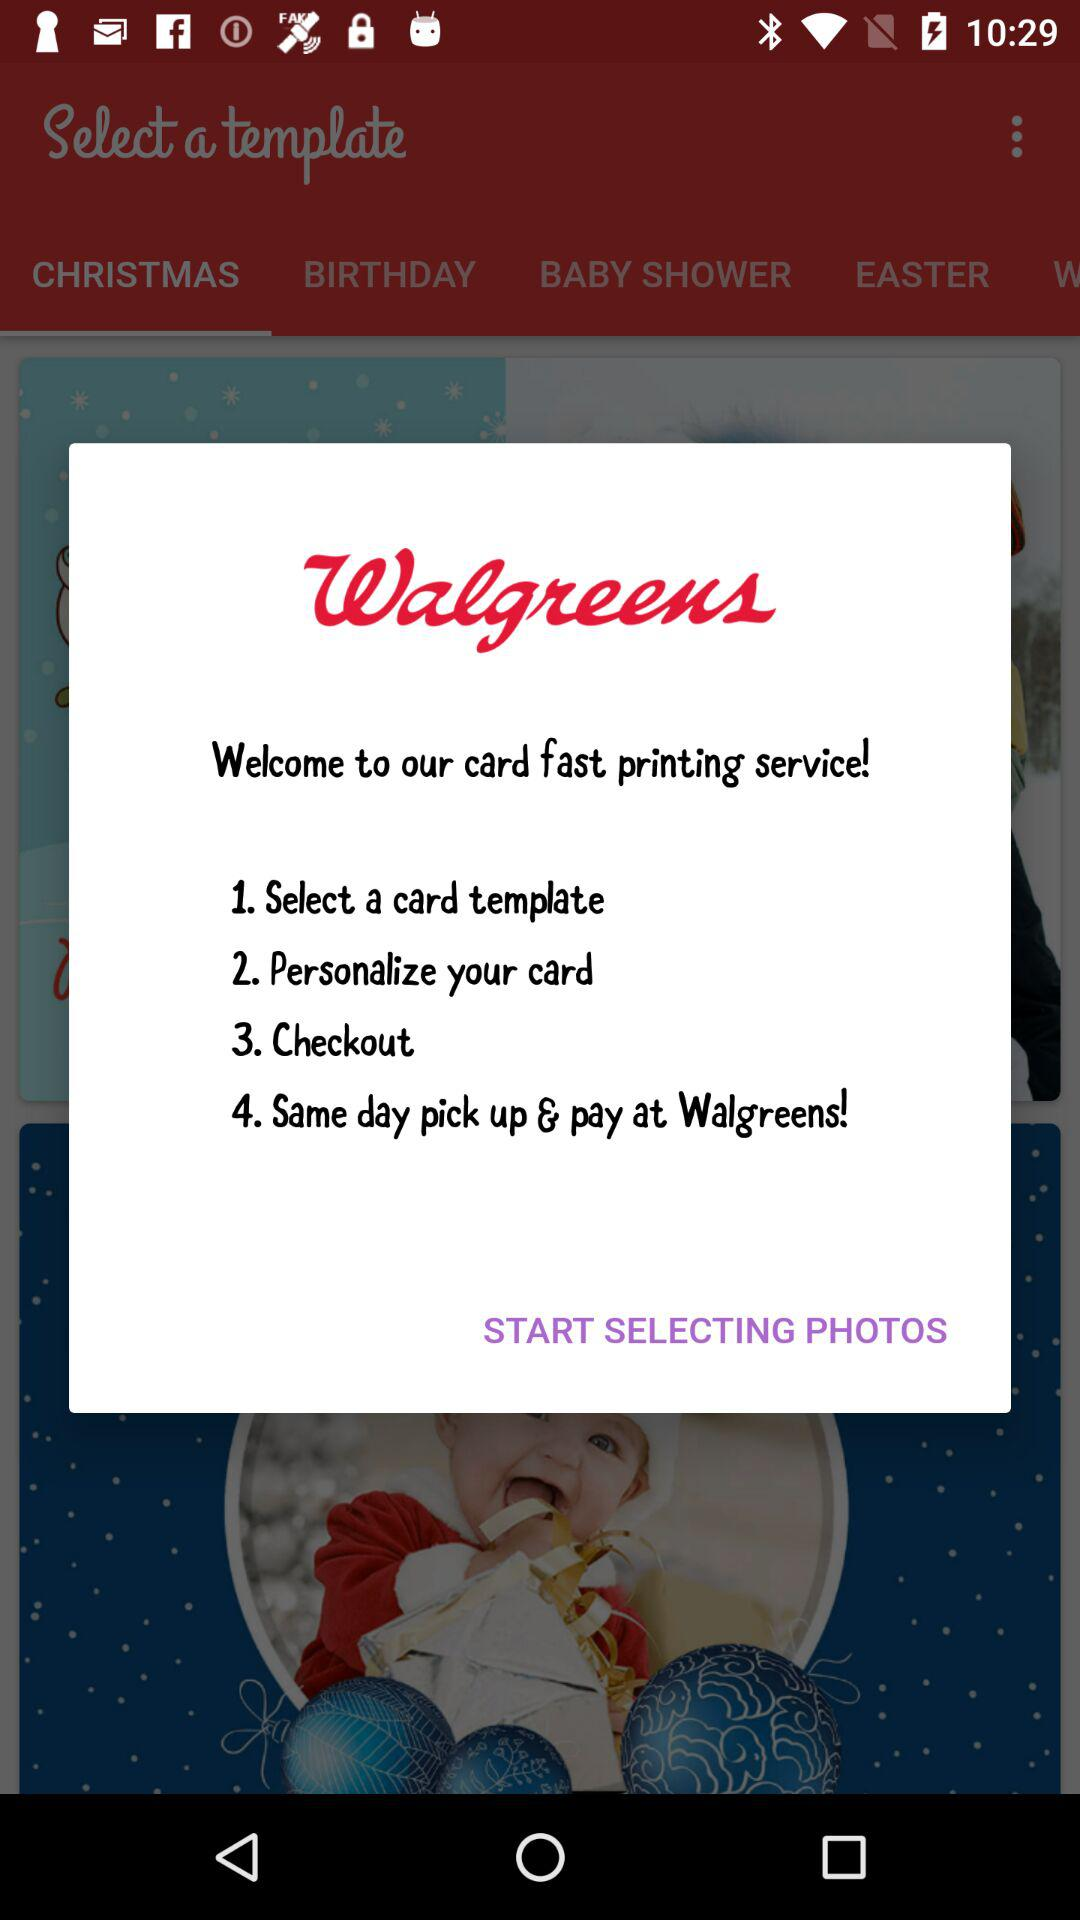What is the name of the application? The name of the application is "Walgreens". 